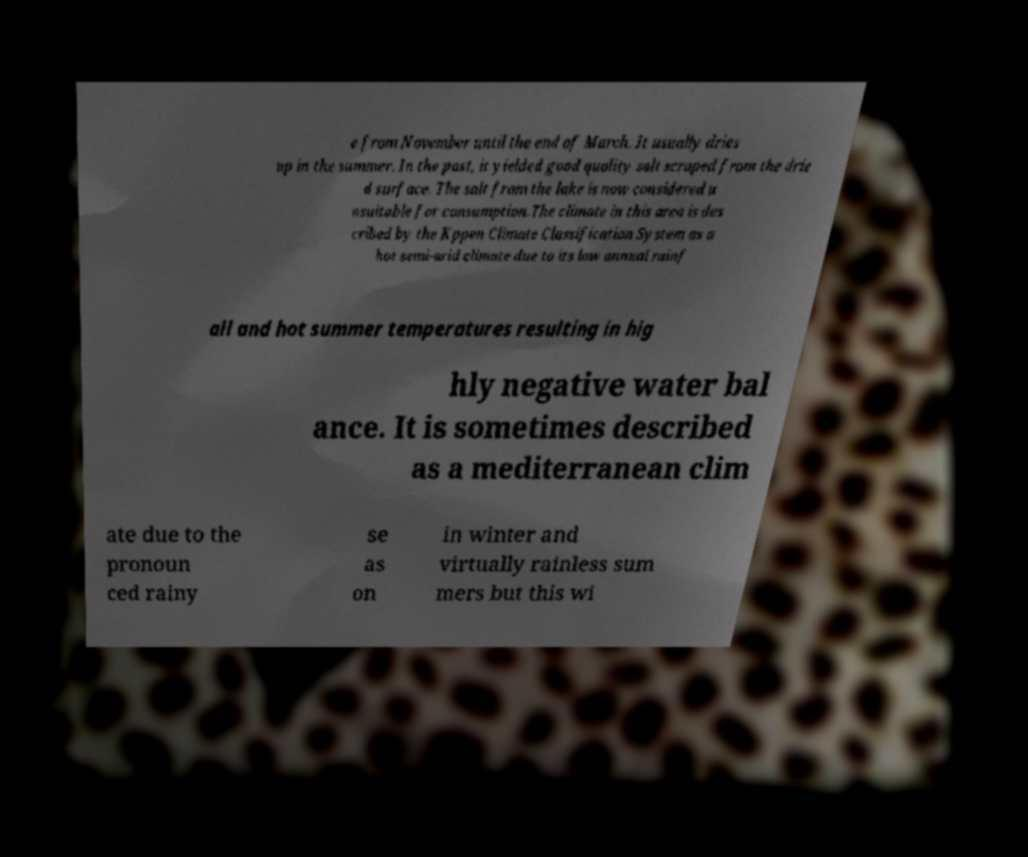Please read and relay the text visible in this image. What does it say? e from November until the end of March. It usually dries up in the summer. In the past, it yielded good quality salt scraped from the drie d surface. The salt from the lake is now considered u nsuitable for consumption.The climate in this area is des cribed by the Kppen Climate Classification System as a hot semi-arid climate due to its low annual rainf all and hot summer temperatures resulting in hig hly negative water bal ance. It is sometimes described as a mediterranean clim ate due to the pronoun ced rainy se as on in winter and virtually rainless sum mers but this wi 